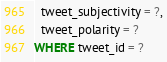Convert code to text. <code><loc_0><loc_0><loc_500><loc_500><_SQL_>  tweet_subjectivity = ?,
  tweet_polarity = ?
WHERE tweet_id = ?
</code> 